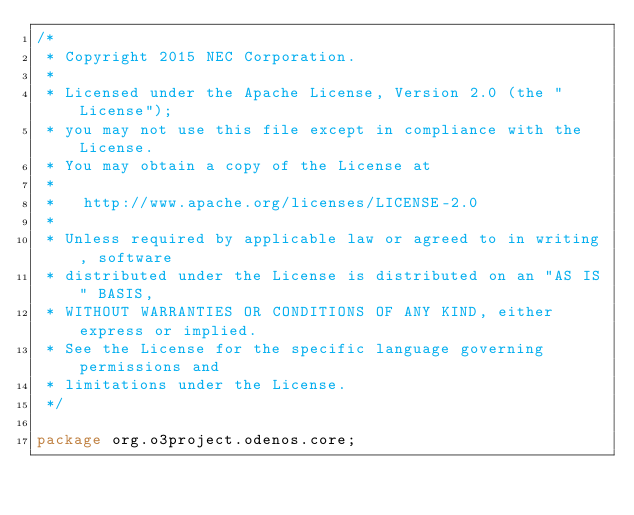Convert code to text. <code><loc_0><loc_0><loc_500><loc_500><_Java_>/*
 * Copyright 2015 NEC Corporation.
 *
 * Licensed under the Apache License, Version 2.0 (the "License");
 * you may not use this file except in compliance with the License.
 * You may obtain a copy of the License at
 *
 *   http://www.apache.org/licenses/LICENSE-2.0
 *
 * Unless required by applicable law or agreed to in writing, software
 * distributed under the License is distributed on an "AS IS" BASIS,
 * WITHOUT WARRANTIES OR CONDITIONS OF ANY KIND, either express or implied.
 * See the License for the specific language governing permissions and
 * limitations under the License.
 */

package org.o3project.odenos.core;

</code> 